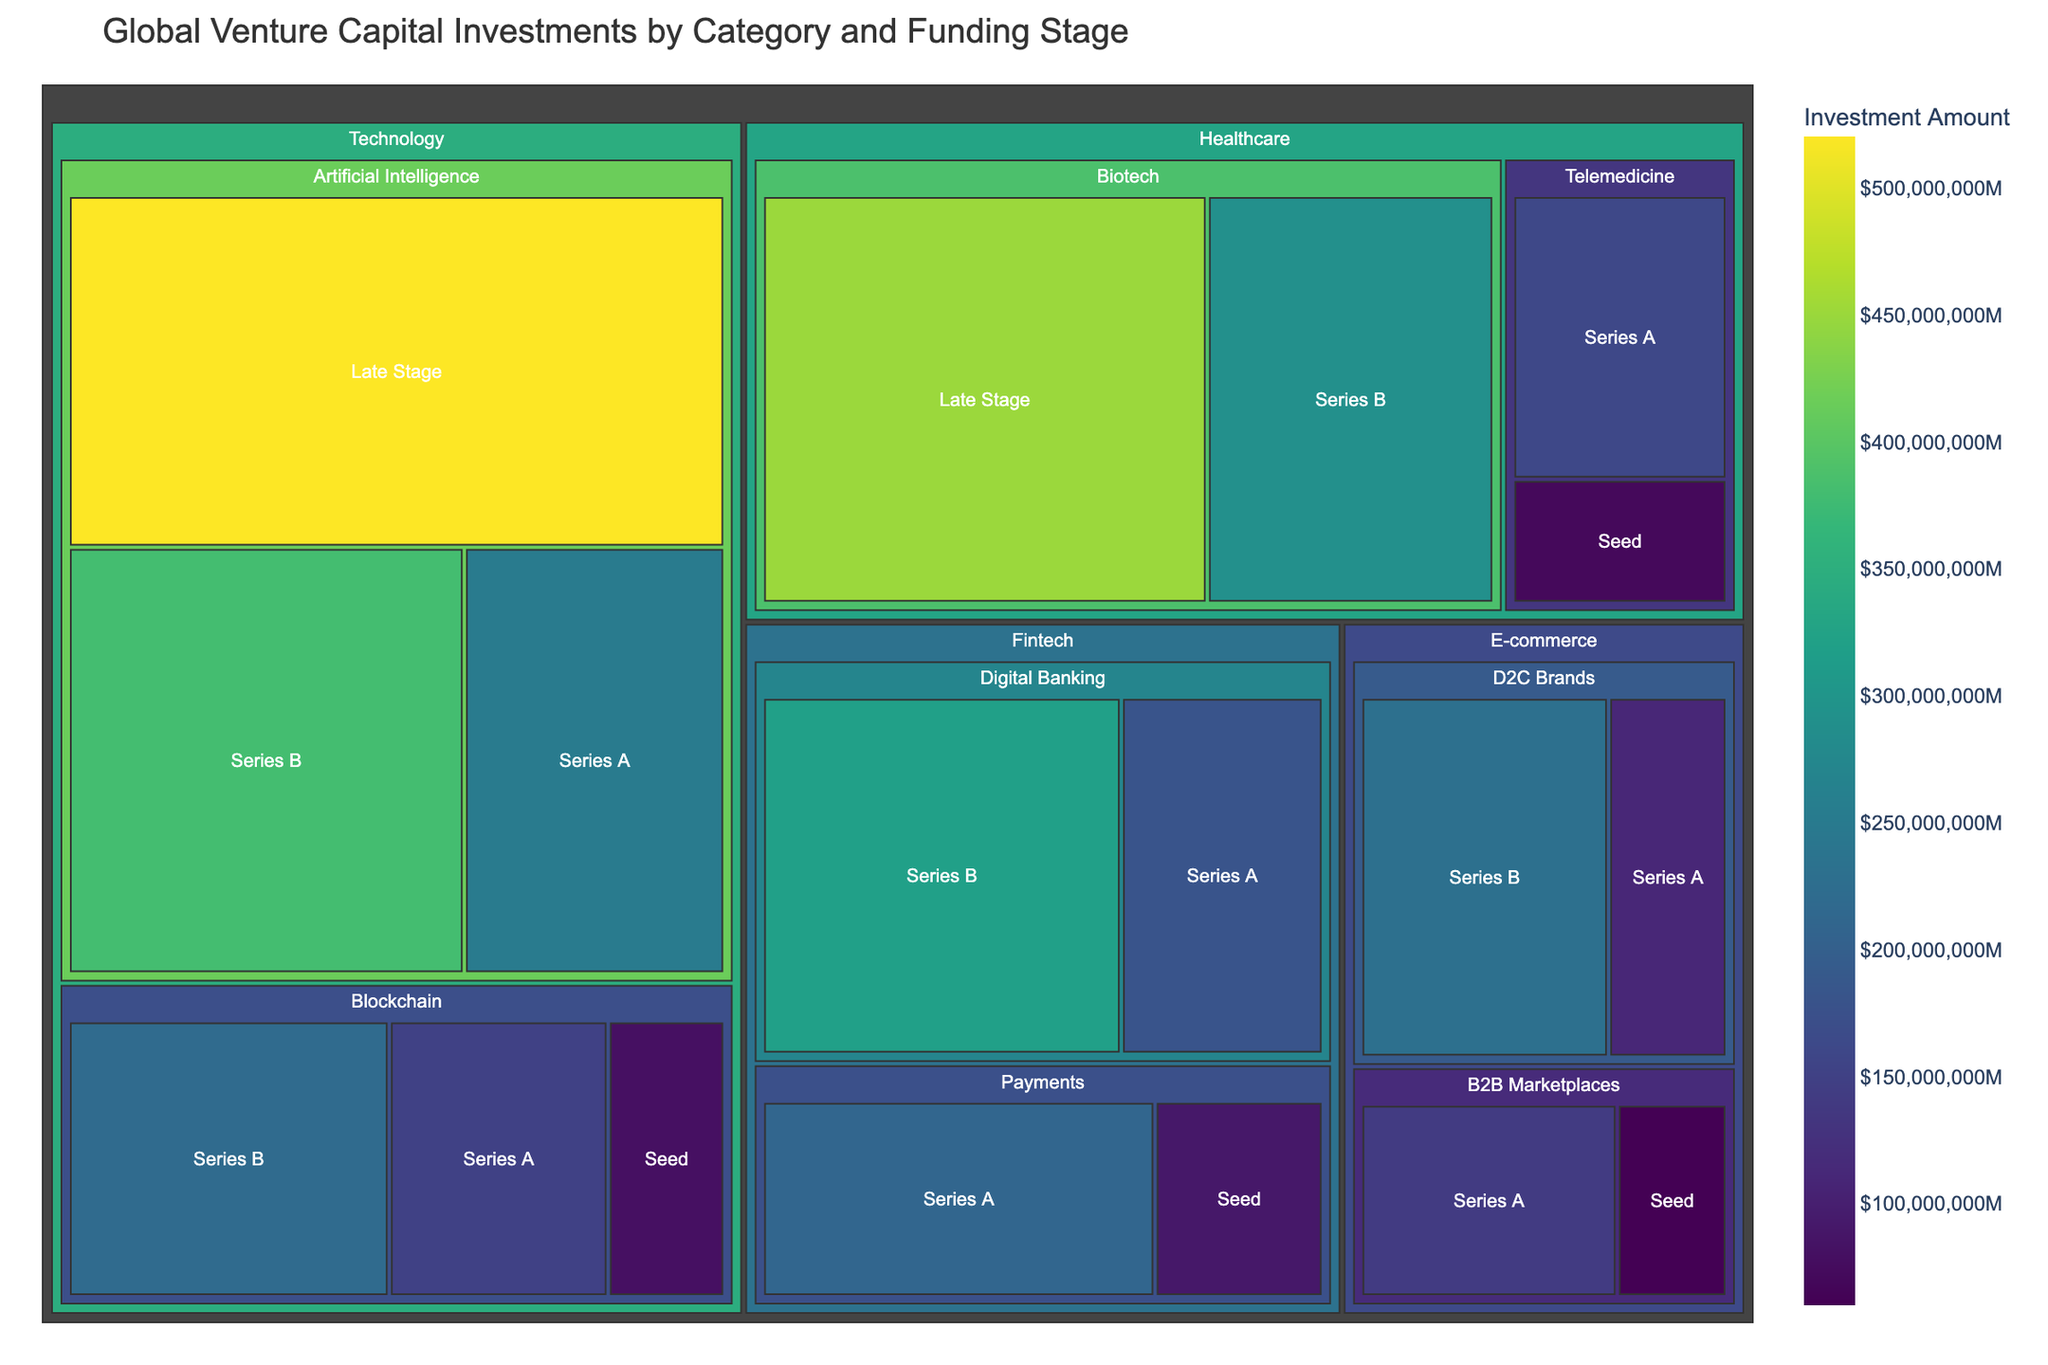What's the title of the figure? The title is displayed at the top of the figure. It summarizes the overall theme and scope of the visualization, helping viewers quickly understand what the plot is about.
Answer: Global Venture Capital Investments by Category and Funding Stage Which subcategory within the Technology category has the highest investment amount? To find this, locate the Technology category and compare the investment amounts listed for the subcategories. Look for the one with the highest value.
Answer: Artificial Intelligence What is the investment amount for Telemedicine in the Seed stage? Navigate to the Healthcare category and identify the Telemedicine subcategory. The Seed stage investment can be read directly from the figure.
Answer: $70M Which category has the lowest total investment amount? Sum the investment amounts for each category. Compare these sums to identify the category with the lowest total.
Answer: E-commerce What is the total investment in the Fintech category at the Series A stage? Find all investment amounts for Series A within the Fintech category and sum them up. For Fintech, Series A has investments in Digital Banking ($180M) and Payments ($210M). So, the total is $180M + $210M.
Answer: $390M Compare the investment in Biotech (Late Stage) to Artificial Intelligence (Late Stage). Which one is higher and by how much? Locate the investment amounts for Biotech and Artificial Intelligence in the Late Stage. Subtract the smaller amount from the larger to find the difference. Biotech (Late Stage) is $450M and Artificial Intelligence (Late Stage) is $520M. The difference is $520M - $450M.
Answer: Artificial Intelligence is higher by $70M What's the combined investment for Digital Banking across all stages? Add up the investment amounts for Digital Banking from each stage: Series A ($180M) and Series B ($320M). The combined investment is $180M + $320M.
Answer: $500M Which funding stage has the largest investment within the Blockchain subcategory? Locate the Blockchain subcategory and compare the investment amounts of different stages to identify the largest one.
Answer: Series B Calculate the average investment amount for the E-commerce category. Sum up all the investments in the E-commerce category: B2B Marketplaces: Seed ($60M) + Series A ($140M), D2C Brands: Series A ($110M) + Series B ($230M). The total is $60M + $140M + $110M + $230M = $540M. There are 4 data points, so the average is $540M / 4.
Answer: $135M Identify the category with the broadest range of funding stages. Determine which category has the most unique funding stages listed (Seed, Series A, Series B, Late Stage). Count each funding stage within each category and find the maximum.
Answer: Technology 